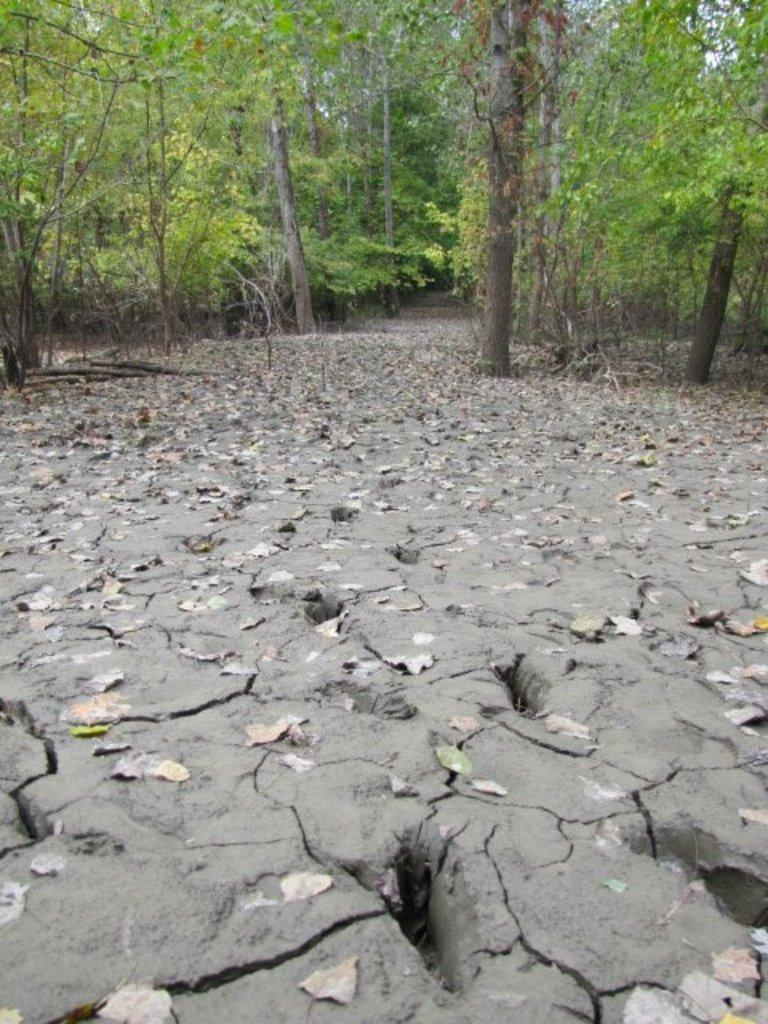What type of vegetation can be seen at the bottom of the image? There are leaves on the land at the bottom of the image. What can be seen at the top of the image? There are trees visible at the top of the image. Can you describe the landscape in the image? The image features a landscape with leaves on the ground at the bottom and trees at the top. What type of calculator can be seen in the image? There is no calculator present in the image. What kind of spark can be observed in the image? There is no spark visible in the image. 